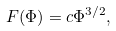Convert formula to latex. <formula><loc_0><loc_0><loc_500><loc_500>F ( \Phi ) = c \Phi ^ { 3 / 2 } ,</formula> 